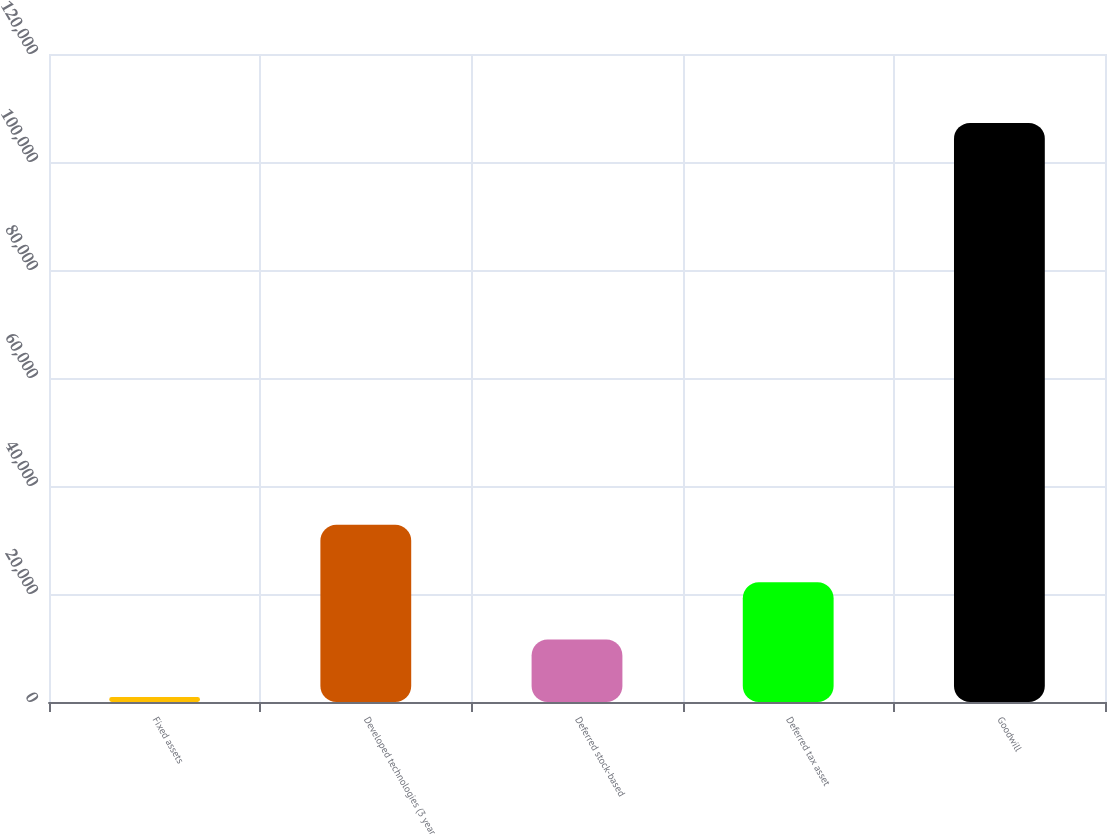Convert chart. <chart><loc_0><loc_0><loc_500><loc_500><bar_chart><fcel>Fixed assets<fcel>Developed technologies (3 year<fcel>Deferred stock-based<fcel>Deferred tax asset<fcel>Goodwill<nl><fcel>921<fcel>32814.9<fcel>11552.3<fcel>22183.6<fcel>107234<nl></chart> 